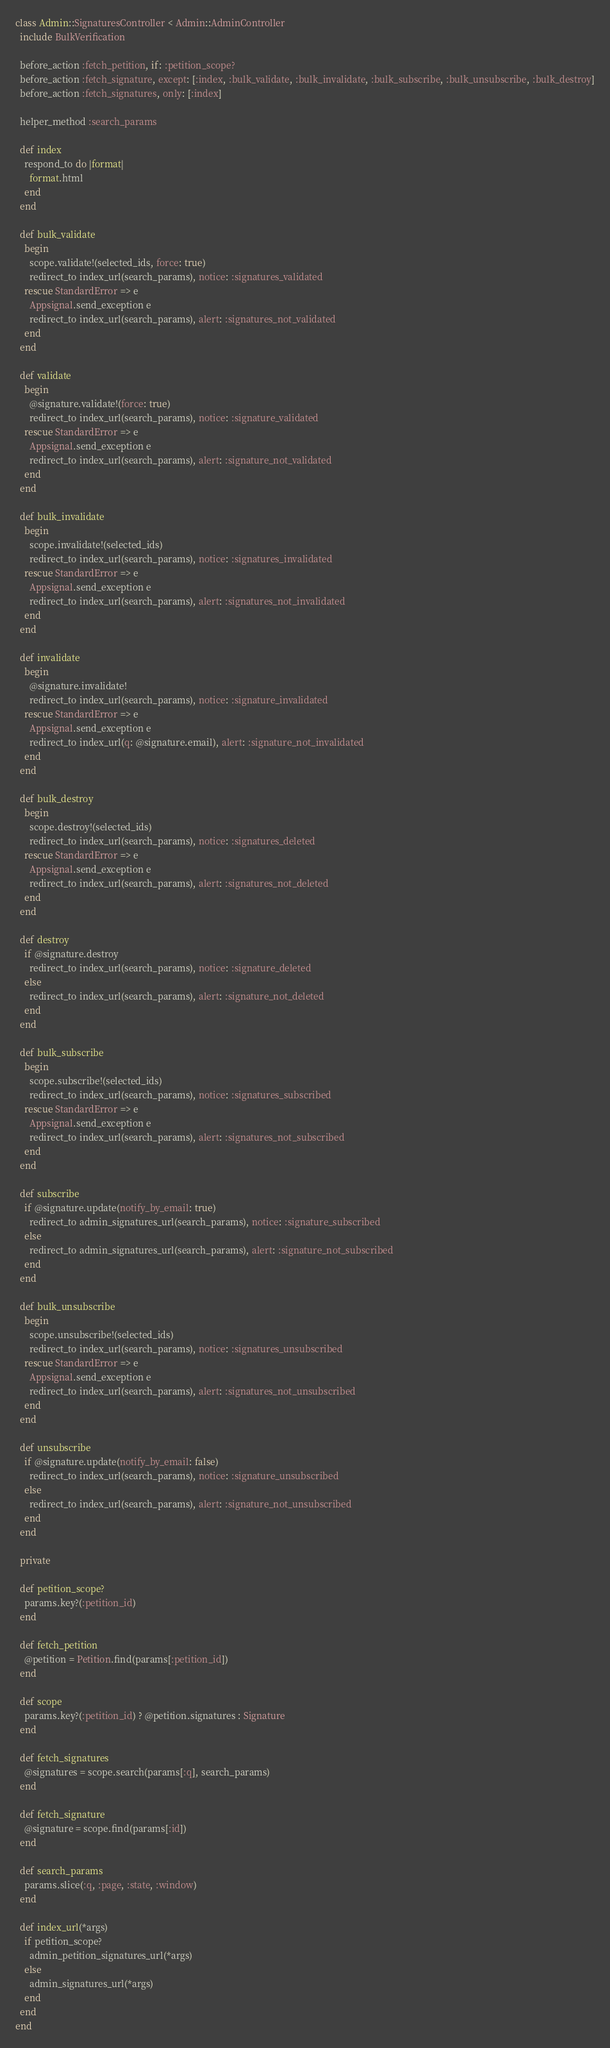Convert code to text. <code><loc_0><loc_0><loc_500><loc_500><_Ruby_>class Admin::SignaturesController < Admin::AdminController
  include BulkVerification

  before_action :fetch_petition, if: :petition_scope?
  before_action :fetch_signature, except: [:index, :bulk_validate, :bulk_invalidate, :bulk_subscribe, :bulk_unsubscribe, :bulk_destroy]
  before_action :fetch_signatures, only: [:index]

  helper_method :search_params

  def index
    respond_to do |format|
      format.html
    end
  end

  def bulk_validate
    begin
      scope.validate!(selected_ids, force: true)
      redirect_to index_url(search_params), notice: :signatures_validated
    rescue StandardError => e
      Appsignal.send_exception e
      redirect_to index_url(search_params), alert: :signatures_not_validated
    end
  end

  def validate
    begin
      @signature.validate!(force: true)
      redirect_to index_url(search_params), notice: :signature_validated
    rescue StandardError => e
      Appsignal.send_exception e
      redirect_to index_url(search_params), alert: :signature_not_validated
    end
  end

  def bulk_invalidate
    begin
      scope.invalidate!(selected_ids)
      redirect_to index_url(search_params), notice: :signatures_invalidated
    rescue StandardError => e
      Appsignal.send_exception e
      redirect_to index_url(search_params), alert: :signatures_not_invalidated
    end
  end

  def invalidate
    begin
      @signature.invalidate!
      redirect_to index_url(search_params), notice: :signature_invalidated
    rescue StandardError => e
      Appsignal.send_exception e
      redirect_to index_url(q: @signature.email), alert: :signature_not_invalidated
    end
  end

  def bulk_destroy
    begin
      scope.destroy!(selected_ids)
      redirect_to index_url(search_params), notice: :signatures_deleted
    rescue StandardError => e
      Appsignal.send_exception e
      redirect_to index_url(search_params), alert: :signatures_not_deleted
    end
  end

  def destroy
    if @signature.destroy
      redirect_to index_url(search_params), notice: :signature_deleted
    else
      redirect_to index_url(search_params), alert: :signature_not_deleted
    end
  end

  def bulk_subscribe
    begin
      scope.subscribe!(selected_ids)
      redirect_to index_url(search_params), notice: :signatures_subscribed
    rescue StandardError => e
      Appsignal.send_exception e
      redirect_to index_url(search_params), alert: :signatures_not_subscribed
    end
  end

  def subscribe
    if @signature.update(notify_by_email: true)
      redirect_to admin_signatures_url(search_params), notice: :signature_subscribed
    else
      redirect_to admin_signatures_url(search_params), alert: :signature_not_subscribed
    end
  end

  def bulk_unsubscribe
    begin
      scope.unsubscribe!(selected_ids)
      redirect_to index_url(search_params), notice: :signatures_unsubscribed
    rescue StandardError => e
      Appsignal.send_exception e
      redirect_to index_url(search_params), alert: :signatures_not_unsubscribed
    end
  end

  def unsubscribe
    if @signature.update(notify_by_email: false)
      redirect_to index_url(search_params), notice: :signature_unsubscribed
    else
      redirect_to index_url(search_params), alert: :signature_not_unsubscribed
    end
  end

  private

  def petition_scope?
    params.key?(:petition_id)
  end

  def fetch_petition
    @petition = Petition.find(params[:petition_id])
  end

  def scope
    params.key?(:petition_id) ? @petition.signatures : Signature
  end

  def fetch_signatures
    @signatures = scope.search(params[:q], search_params)
  end

  def fetch_signature
    @signature = scope.find(params[:id])
  end

  def search_params
    params.slice(:q, :page, :state, :window)
  end

  def index_url(*args)
    if petition_scope?
      admin_petition_signatures_url(*args)
    else
      admin_signatures_url(*args)
    end
  end
end
</code> 